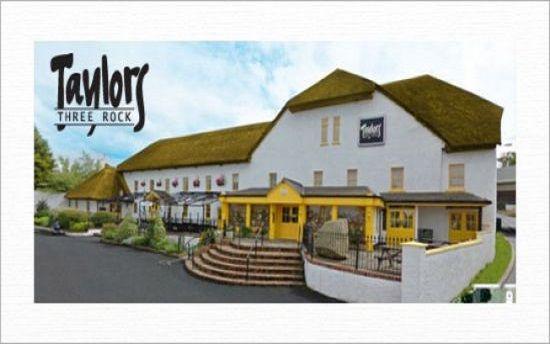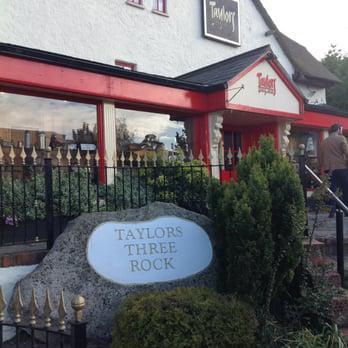The first image is the image on the left, the second image is the image on the right. For the images shown, is this caption "In one image, at least one rightward-facing dog figure is on the rooftop of a large, pale colored building with red entrance doors." true? Answer yes or no. No. The first image is the image on the left, the second image is the image on the right. Assess this claim about the two images: "There are wide, curved steps in front of the red door in the image on the left.". Correct or not? Answer yes or no. No. 